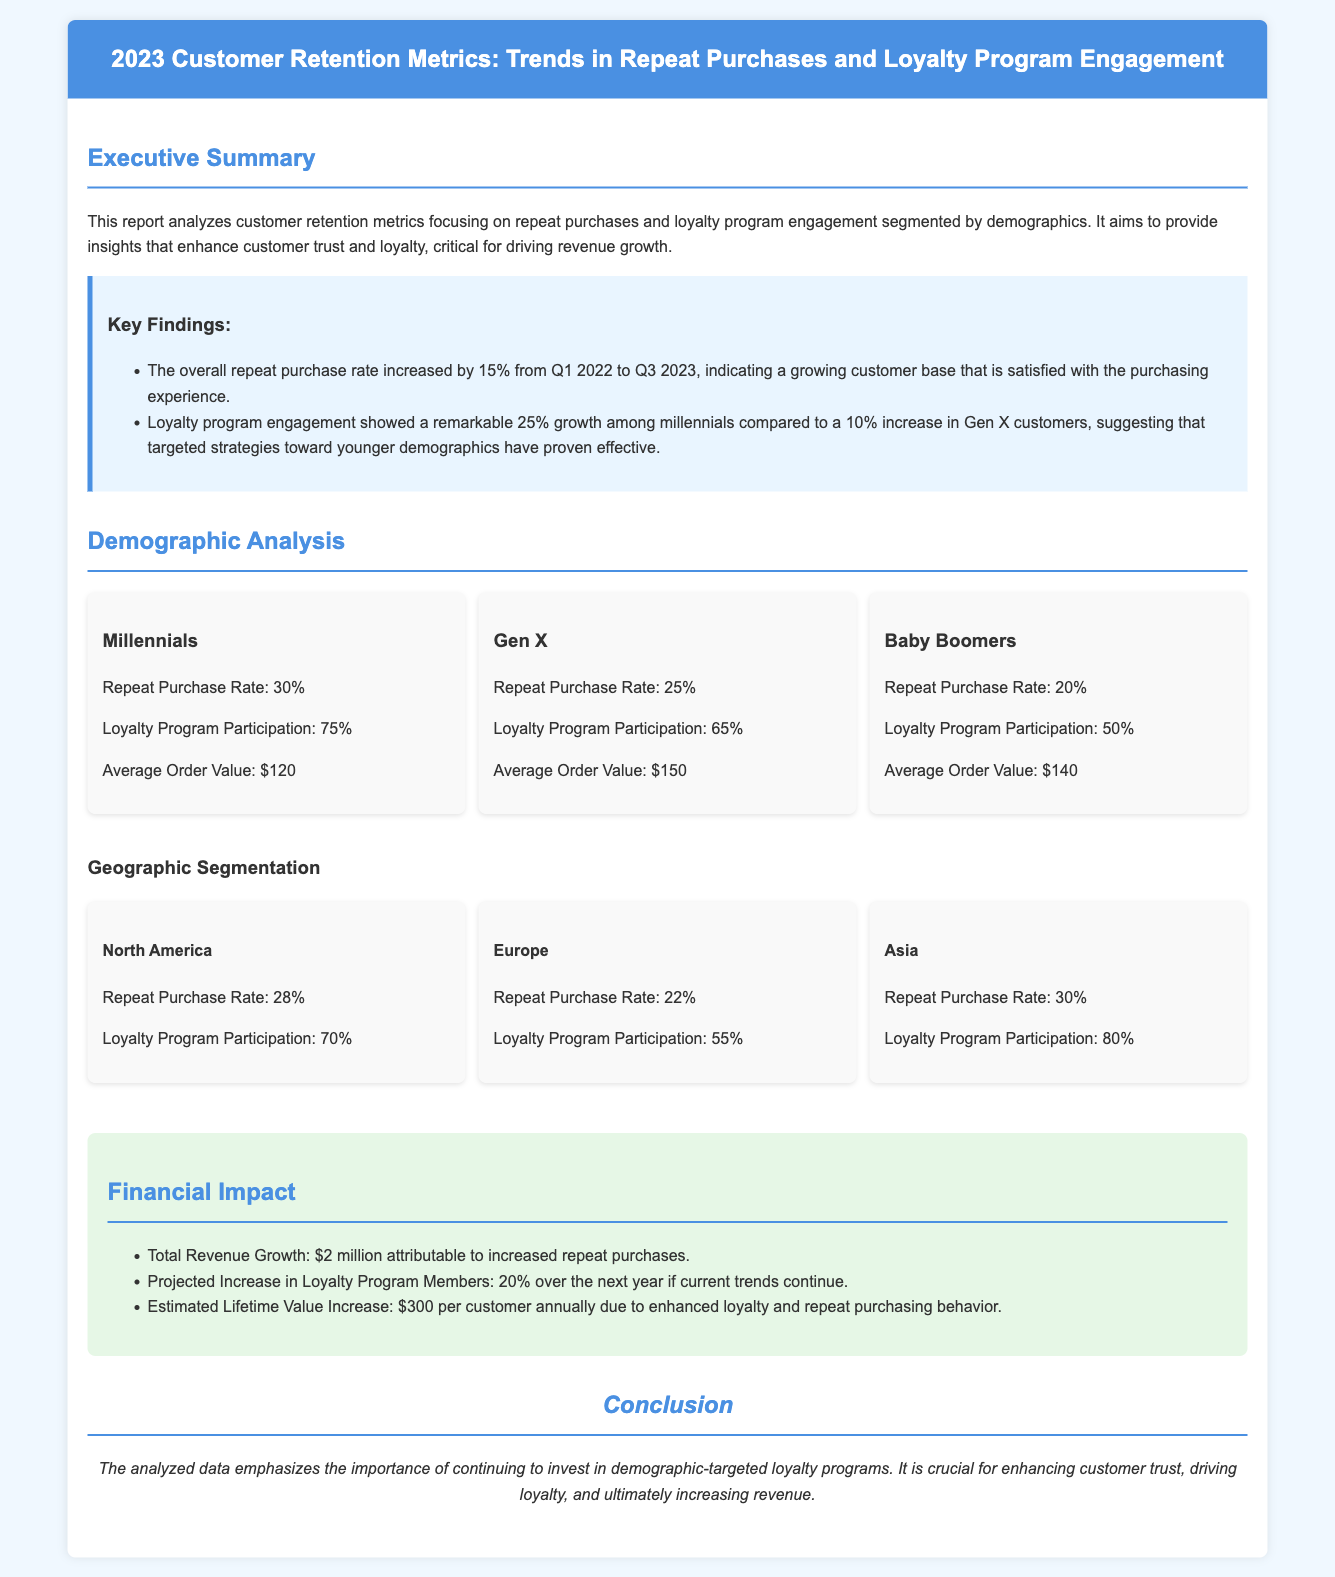What is the overall repeat purchase rate increase from Q1 2022 to Q3 2023? The report states that the overall repeat purchase rate increased by 15% during this period.
Answer: 15% Which demographic has the highest loyalty program participation? The document indicates that Millennials have the highest loyalty program participation at 75%.
Answer: 75% What is the repeat purchase rate for Baby Boomers? The repeat purchase rate for Baby Boomers is found to be 20% in the demographics section.
Answer: 20% How much total revenue growth is attributable to increased repeat purchases? The report mentions that total revenue growth attributable to increased repeat purchases is $2 million.
Answer: $2 million What is the average order value for Gen X customers? According to the demographic analysis, the average order value for Gen X customers is $150.
Answer: $150 Which region has a loyalty program participation rate of 80%? The demographic analysis shows that the Asia region has a loyalty program participation rate of 80%.
Answer: Asia What is the projected increase in loyalty program members over the next year? The report projects a 20% increase in loyalty program members over the next year if current trends continue.
Answer: 20% Which customer group showed a 25% growth in loyalty program engagement? The document states that Millennials showed a remarkable 25% growth in loyalty program engagement.
Answer: Millennials 